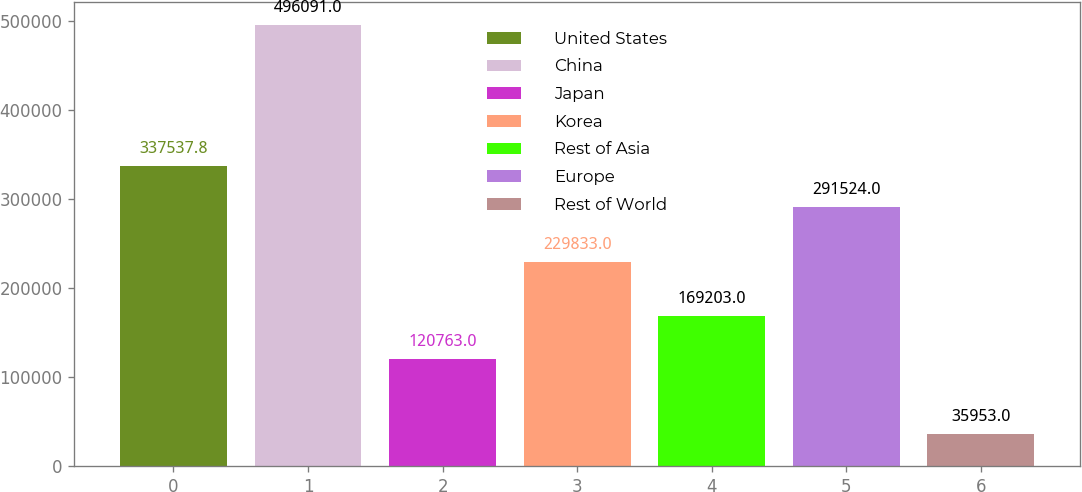Convert chart. <chart><loc_0><loc_0><loc_500><loc_500><bar_chart><fcel>United States<fcel>China<fcel>Japan<fcel>Korea<fcel>Rest of Asia<fcel>Europe<fcel>Rest of World<nl><fcel>337538<fcel>496091<fcel>120763<fcel>229833<fcel>169203<fcel>291524<fcel>35953<nl></chart> 